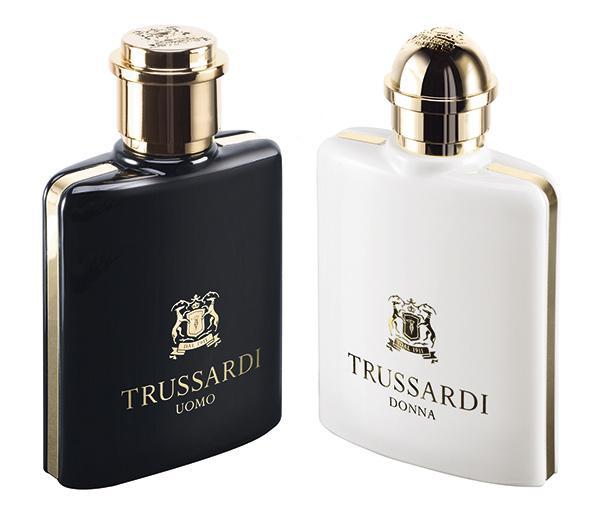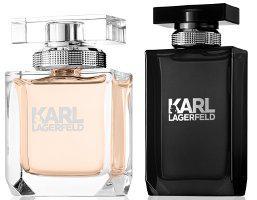The first image is the image on the left, the second image is the image on the right. Considering the images on both sides, is "Each image includes exactly two objects, and one image features an upright angled black bottle to the left of an upright angled white bottle." valid? Answer yes or no. Yes. The first image is the image on the left, the second image is the image on the right. Analyze the images presented: Is the assertion "There is a rectangular cap to a vial in one of the images." valid? Answer yes or no. Yes. 